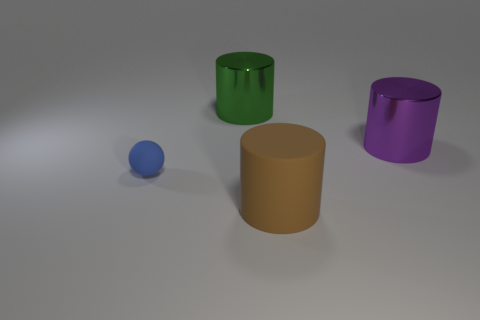Does the large cylinder in front of the tiny blue rubber sphere have the same material as the large green cylinder behind the blue object?
Provide a succinct answer. No. What number of large purple cylinders are there?
Provide a short and direct response. 1. How many large brown objects have the same shape as the tiny thing?
Provide a short and direct response. 0. Do the purple metal thing and the tiny matte thing have the same shape?
Give a very brief answer. No. The green object has what size?
Make the answer very short. Large. How many rubber balls are the same size as the green object?
Your answer should be very brief. 0. Does the thing that is in front of the tiny sphere have the same size as the metallic cylinder left of the purple shiny cylinder?
Your answer should be very brief. Yes. What shape is the small object in front of the purple cylinder?
Provide a short and direct response. Sphere. There is a thing to the left of the large shiny thing that is on the left side of the large purple shiny object; what is its material?
Your response must be concise. Rubber. Are there any big cylinders that have the same color as the small matte sphere?
Provide a succinct answer. No. 